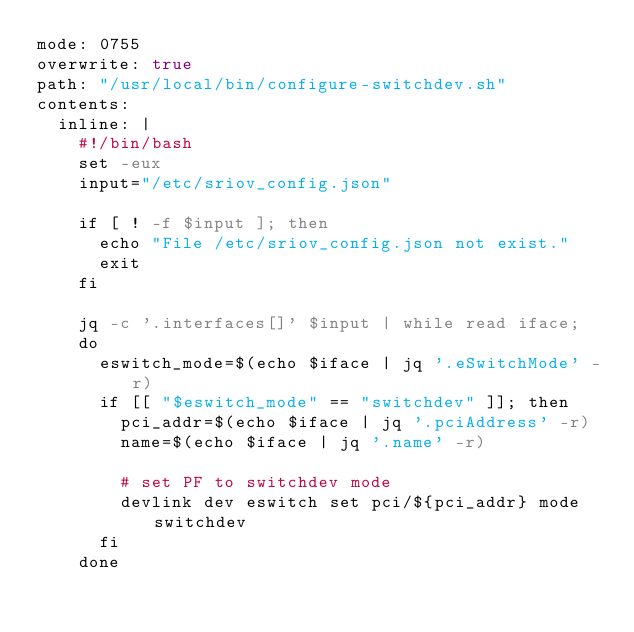<code> <loc_0><loc_0><loc_500><loc_500><_YAML_>mode: 0755
overwrite: true
path: "/usr/local/bin/configure-switchdev.sh"
contents:
  inline: |
    #!/bin/bash
    set -eux
    input="/etc/sriov_config.json"

    if [ ! -f $input ]; then
      echo "File /etc/sriov_config.json not exist."
      exit
    fi

    jq -c '.interfaces[]' $input | while read iface;
    do
      eswitch_mode=$(echo $iface | jq '.eSwitchMode' -r)
      if [[ "$eswitch_mode" == "switchdev" ]]; then
        pci_addr=$(echo $iface | jq '.pciAddress' -r)
        name=$(echo $iface | jq '.name' -r)

        # set PF to switchdev mode
        devlink dev eswitch set pci/${pci_addr} mode switchdev
      fi
    done
</code> 